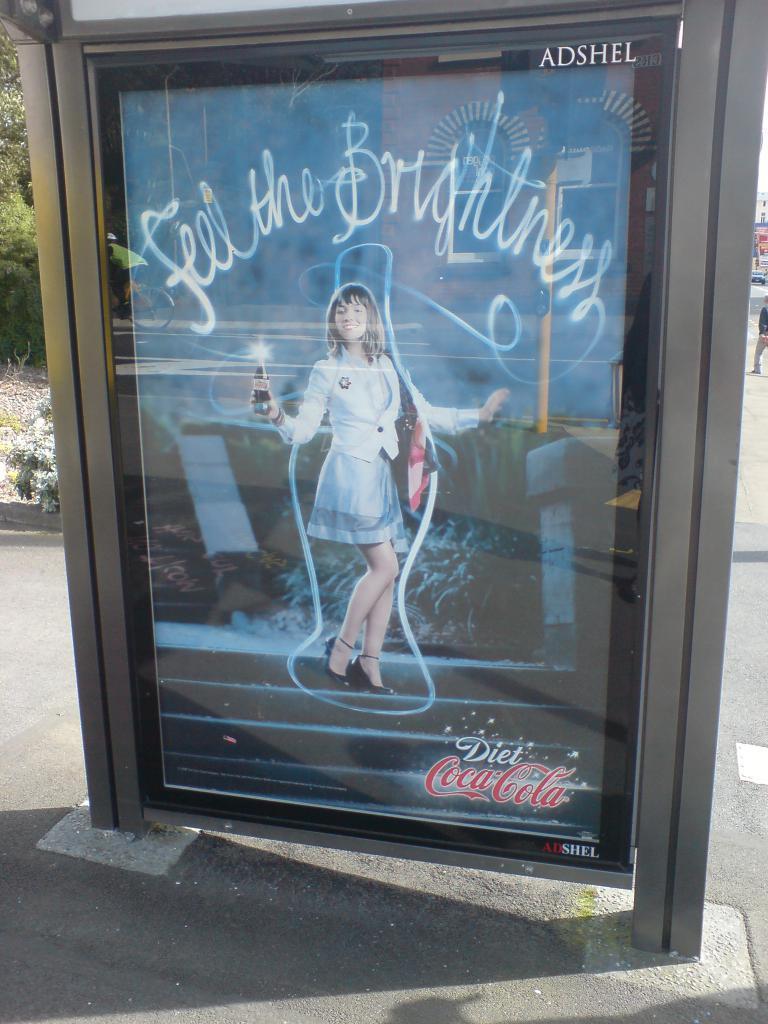Can you describe this image briefly? In this picture there is a board in the foreground, in the board there is a picture of a woman standing and holding the object, at the bottom of the board there is a text. On the left side of the image there is a tree. On the right side of the image there is a building, vehicle and there is a person walking on the road. At the bottom there is a road. 